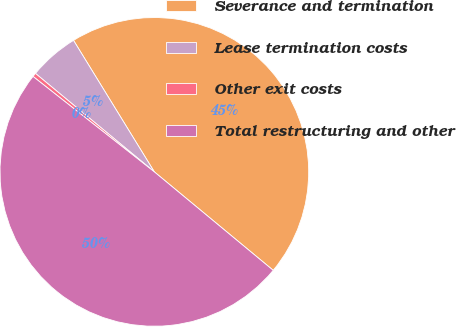Convert chart to OTSL. <chart><loc_0><loc_0><loc_500><loc_500><pie_chart><fcel>Severance and termination<fcel>Lease termination costs<fcel>Other exit costs<fcel>Total restructuring and other<nl><fcel>44.78%<fcel>5.22%<fcel>0.4%<fcel>49.6%<nl></chart> 